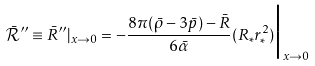<formula> <loc_0><loc_0><loc_500><loc_500>\bar { \mathcal { R } } ^ { \prime \prime } \equiv \bar { R } ^ { \prime \prime } | _ { x \rightarrow 0 } = - \frac { 8 \pi ( \bar { \rho } - 3 \bar { p } ) - \bar { R } } { 6 \bar { \alpha } } ( R _ { * } r _ { * } ^ { 2 } ) \Big | _ { x \rightarrow 0 }</formula> 